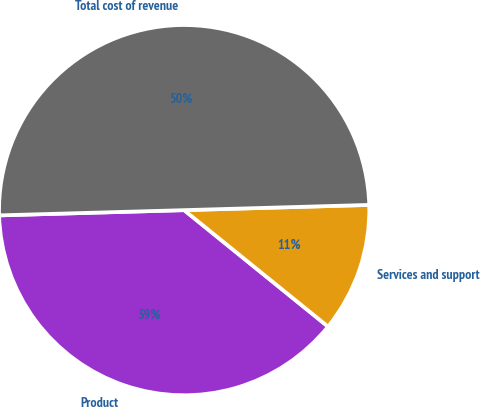<chart> <loc_0><loc_0><loc_500><loc_500><pie_chart><fcel>Product<fcel>Services and support<fcel>Total cost of revenue<nl><fcel>38.72%<fcel>11.28%<fcel>50.0%<nl></chart> 